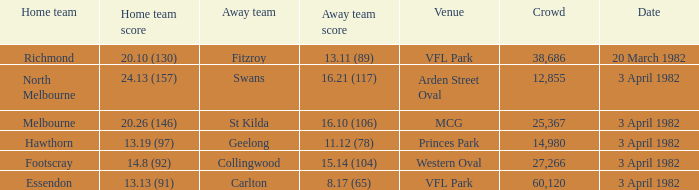Which home team competed against the away team from collingwood? Footscray. 